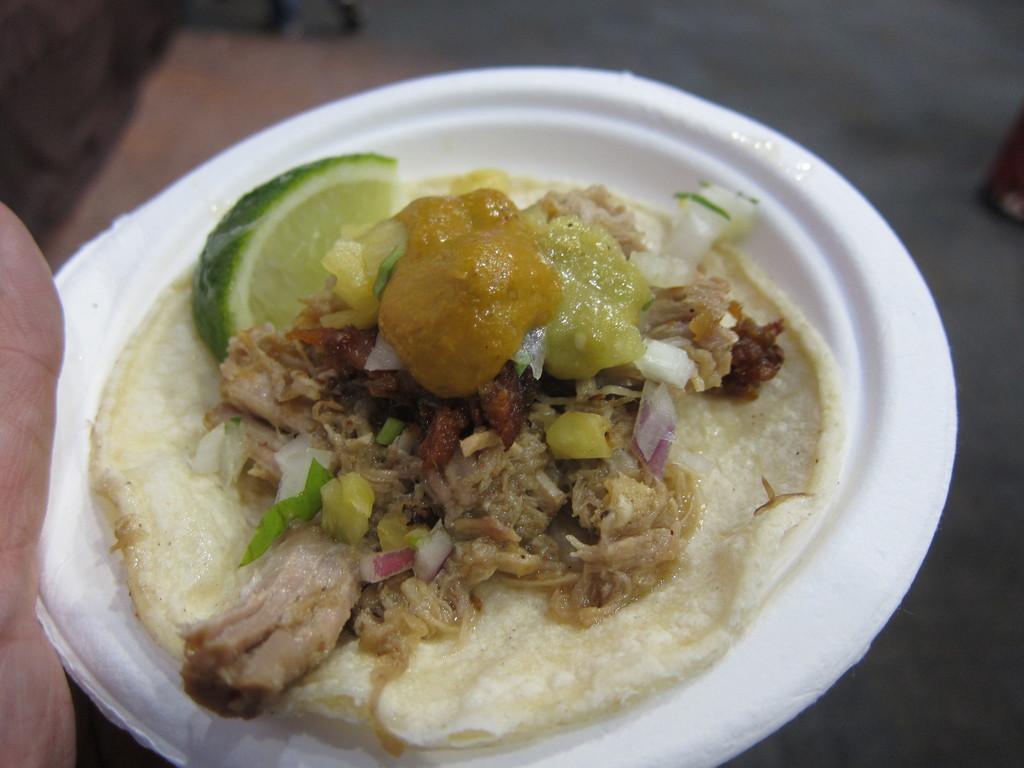How would you summarize this image in a sentence or two? In this image there is a person holding bowl with some food. 